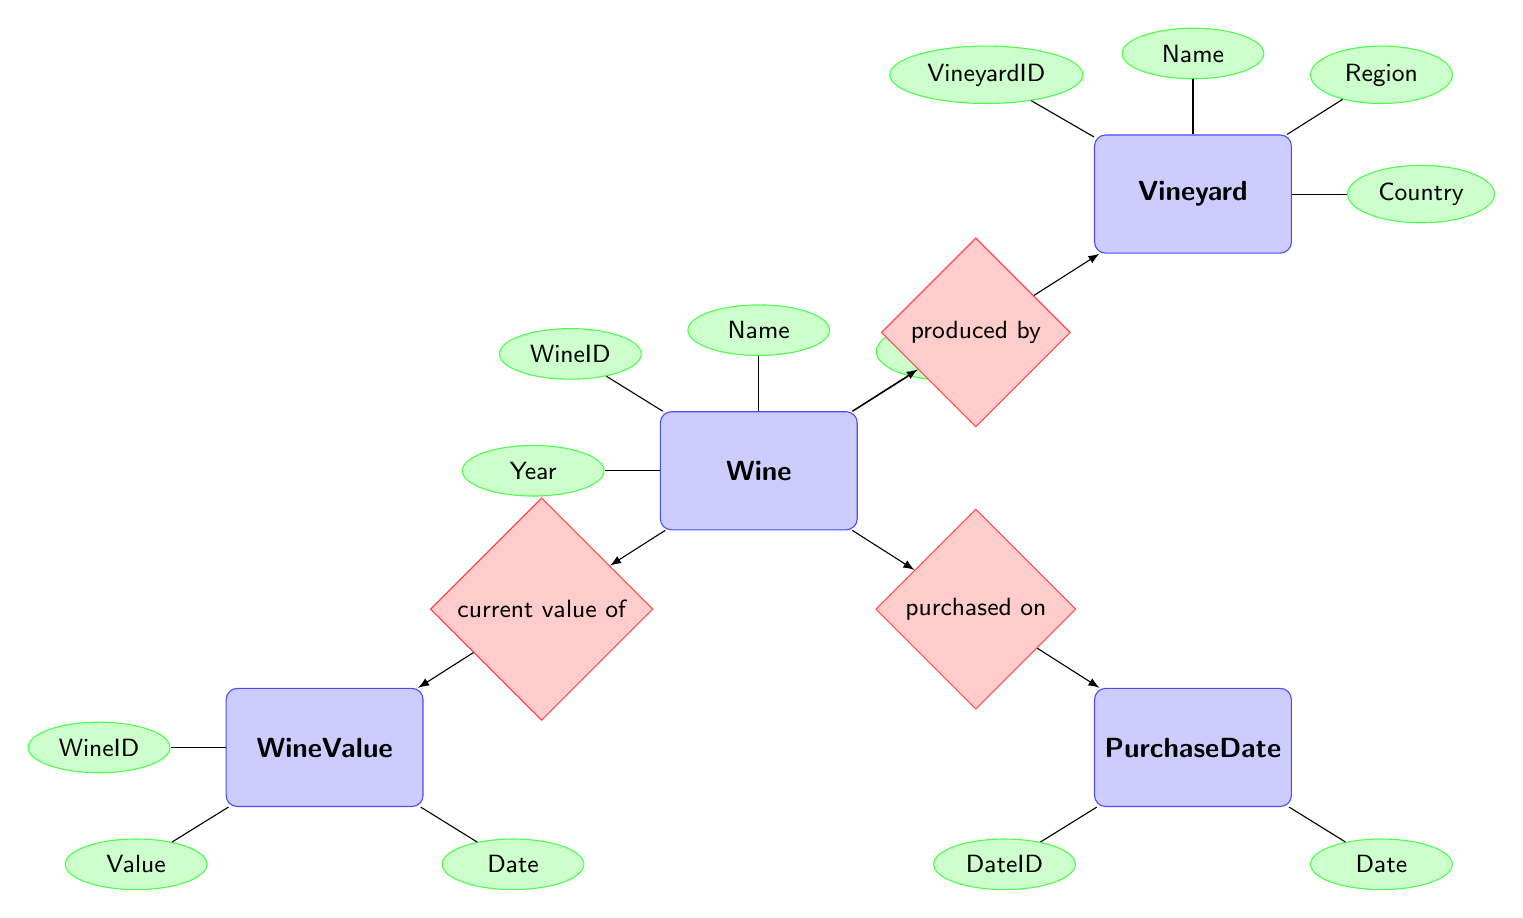What is the relationship between Wine and Vineyard? The diagram indicates that the Wine entity is "produced by" the Vineyard entity. This is represented by the arrow connecting the Wine node to the produced relationship, and then from the produced relationship to the Vineyard node.
Answer: produced by How many attributes does the Vineyard entity have? The Vineyard entity has four attributes: VineyardID, Name, Region, and Country. We can count these attributes as depicted in the diagram under the Vineyard node.
Answer: four What is the purpose of the PurchaseDate entity? The PurchaseDate entity is related to the Wine entity through the relationship "purchased on." This indicates that the PurchaseDate entity is used to record the date when the wine was purchased.
Answer: date Which entity has the attribute "Value"? The WineValue entity contains the attribute "Value". The diagram shows an arrow leading from the WineValue node to the attribute Value, indicating that this attribute belongs to the WineValue entity.
Answer: WineValue What is the main type of relationship involving the PurchaseDate entity? The single relationship involving the PurchaseDate entity is "purchased on," which connects it to the Wine entity. This shows the relationship type between these two entities as depicted in the diagram.
Answer: purchased on How does the Wine entity relate to its current value? The Wine entity is linked to the WineValue entity through the relationship "current value of." This means the WineValue entity provides the current value data for a specific wine.
Answer: current value of What is the name of the entity that contains the attribute "Year"? The attribute "Year" is part of the Wine entity. It is illustrated in the diagram that this attribute is directly connected to the Wine node, showing it belongs to this specific entity.
Answer: Wine Identify the entity associated with the attribute "Country." The attribute "Country" is associated with the Vineyard entity. In the diagram, it is clearly labeled as one of the attributes of the Vineyard node.
Answer: Vineyard Explain the significance of the WineID in the context of value. The WineID in the context of value is significant as it connects the Wine entity with the WineValue entity. The relationship "current value of" indicates that the WineID is used to relate specific wine entries to their respective values.
Answer: WineID connects them 